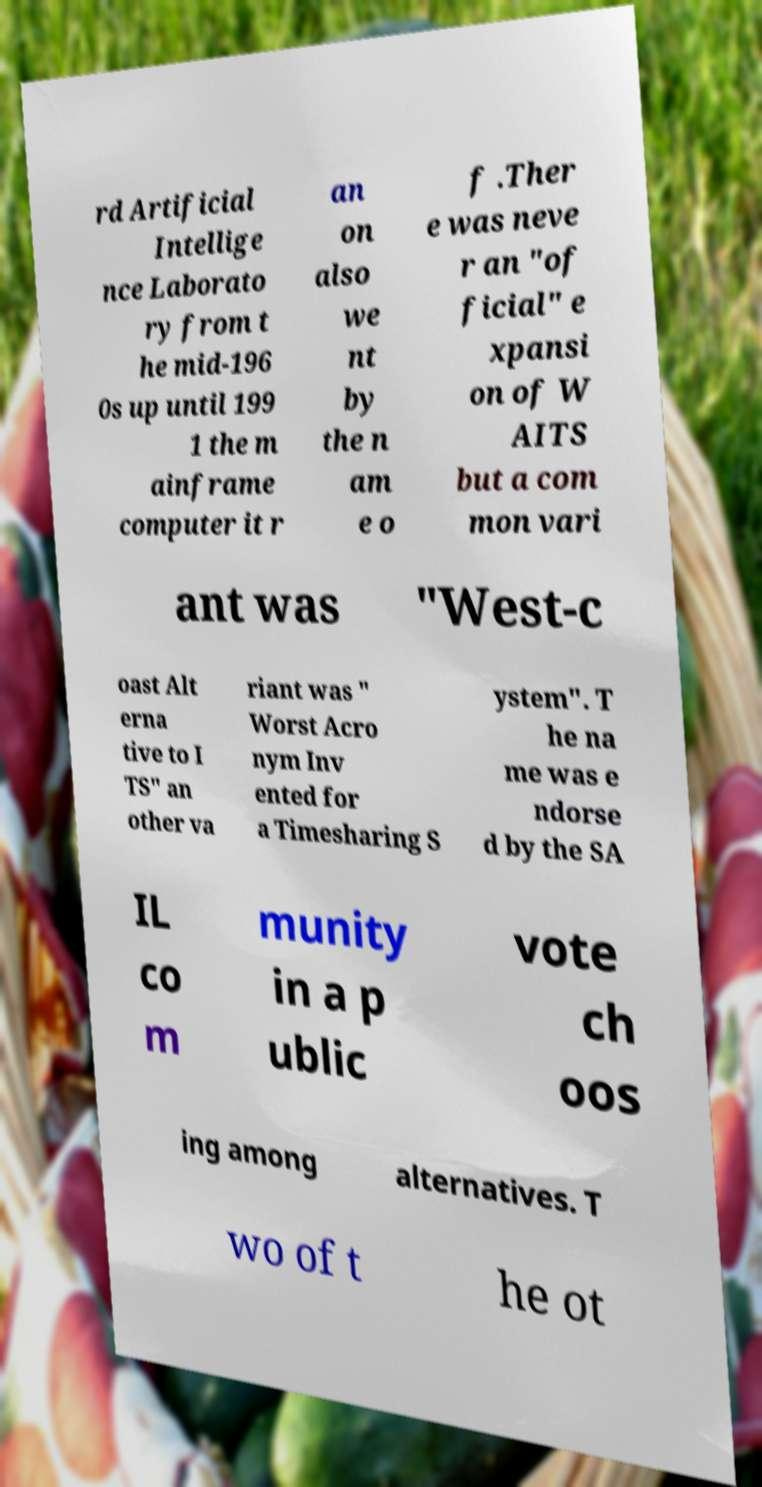Please identify and transcribe the text found in this image. rd Artificial Intellige nce Laborato ry from t he mid-196 0s up until 199 1 the m ainframe computer it r an on also we nt by the n am e o f .Ther e was neve r an "of ficial" e xpansi on of W AITS but a com mon vari ant was "West-c oast Alt erna tive to I TS" an other va riant was " Worst Acro nym Inv ented for a Timesharing S ystem". T he na me was e ndorse d by the SA IL co m munity in a p ublic vote ch oos ing among alternatives. T wo of t he ot 